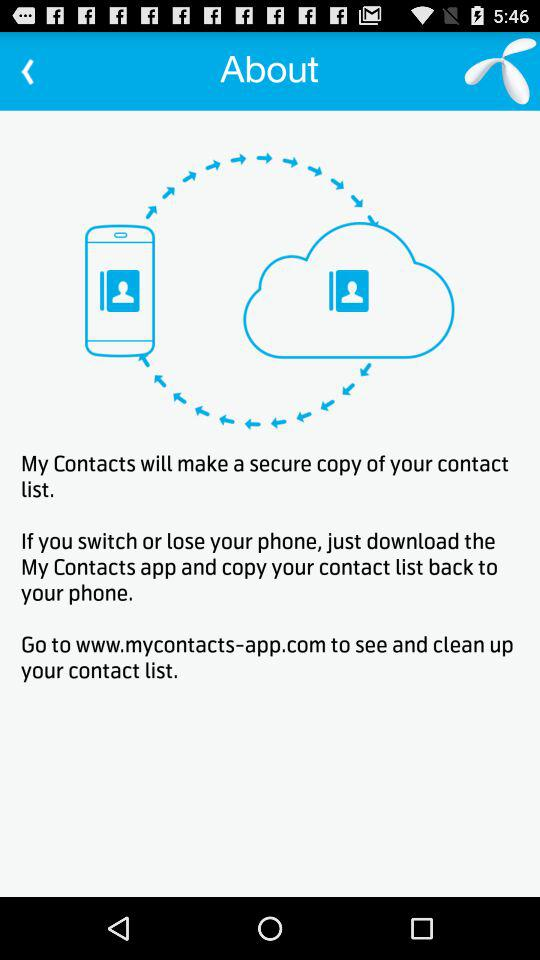What is the name of the application? The name of the application is "My Contacts". 